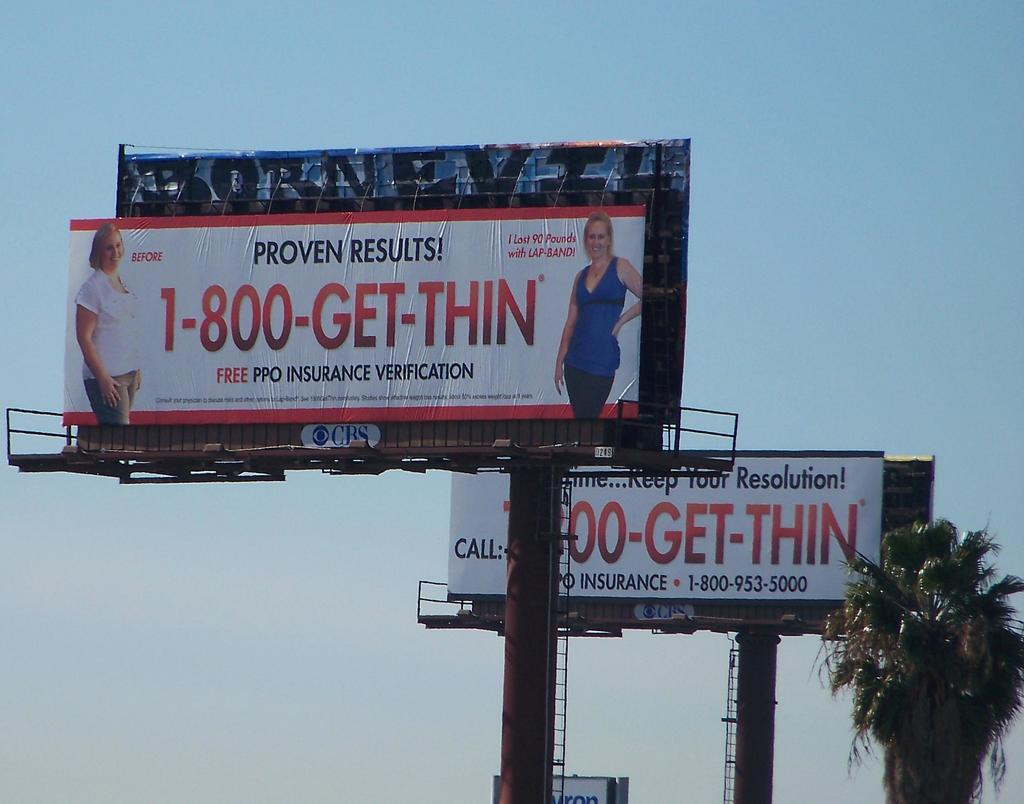<image>
Describe the image concisely. Billboards give the phone number for a weight loss program. 